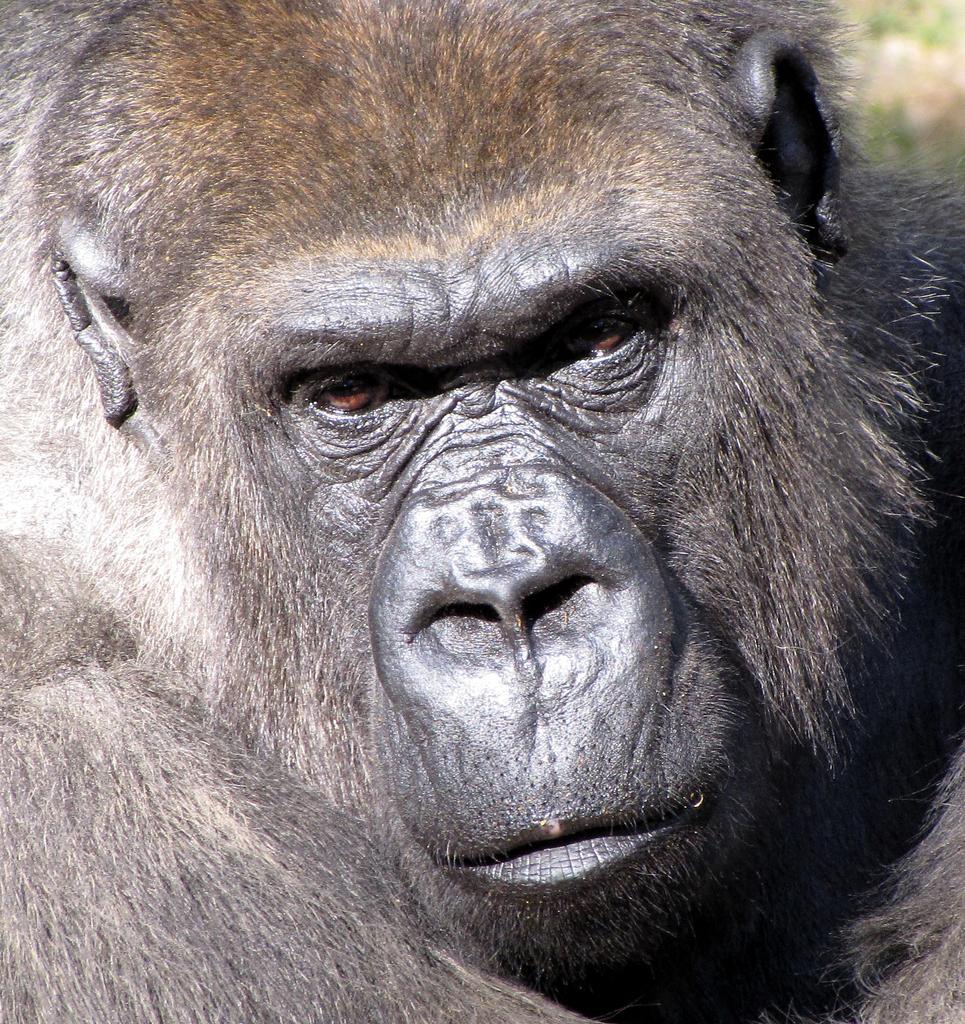Can you describe this image briefly? In this image, I can see the face of a gorilla. There is a blurred background. 